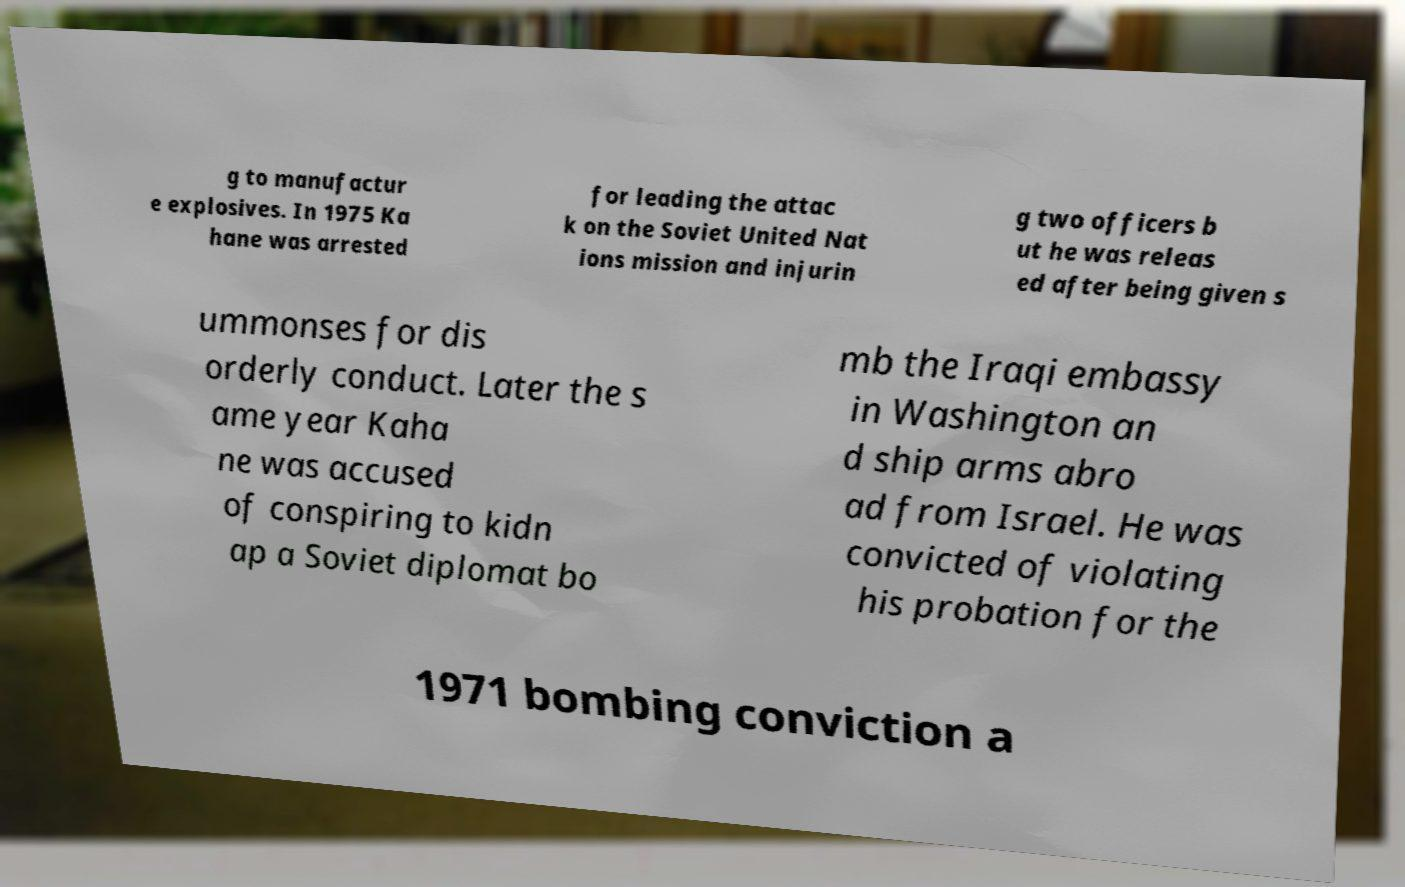I need the written content from this picture converted into text. Can you do that? g to manufactur e explosives. In 1975 Ka hane was arrested for leading the attac k on the Soviet United Nat ions mission and injurin g two officers b ut he was releas ed after being given s ummonses for dis orderly conduct. Later the s ame year Kaha ne was accused of conspiring to kidn ap a Soviet diplomat bo mb the Iraqi embassy in Washington an d ship arms abro ad from Israel. He was convicted of violating his probation for the 1971 bombing conviction a 